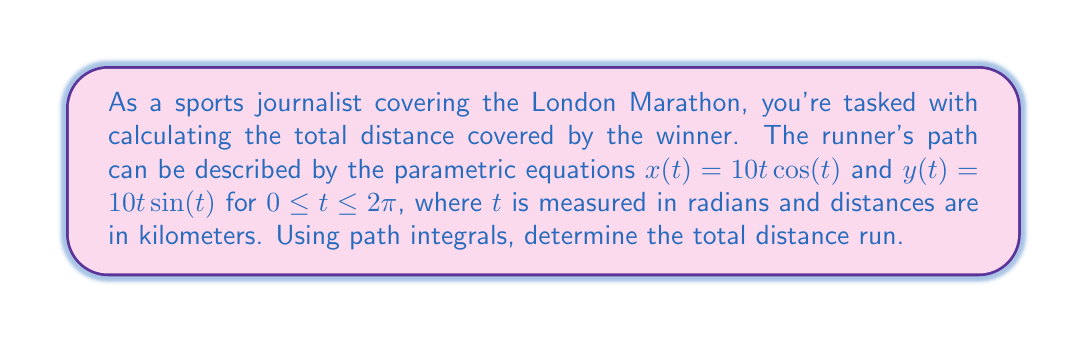What is the answer to this math problem? To solve this problem, we'll use the path integral formula for arc length:

$$L = \int_a^b \sqrt{\left(\frac{dx}{dt}\right)^2 + \left(\frac{dy}{dt}\right)^2} dt$$

Step 1: Calculate $\frac{dx}{dt}$ and $\frac{dy}{dt}$
$\frac{dx}{dt} = 10\cos(t) - 10t\sin(t)$
$\frac{dy}{dt} = 10\sin(t) + 10t\cos(t)$

Step 2: Substitute these into the path integral formula
$$L = \int_0^{2\pi} \sqrt{(10\cos(t) - 10t\sin(t))^2 + (10\sin(t) + 10t\cos(t))^2} dt$$

Step 3: Simplify the expression under the square root
$$(10\cos(t) - 10t\sin(t))^2 + (10\sin(t) + 10t\cos(t))^2$$
$$= 100\cos^2(t) - 200t\cos(t)\sin(t) + 100t^2\sin^2(t) + 100\sin^2(t) + 200t\cos(t)\sin(t) + 100t^2\cos^2(t)$$
$$= 100(\cos^2(t) + \sin^2(t)) + 100t^2(\sin^2(t) + \cos^2(t))$$
$$= 100(1 + t^2)$$

Step 4: Simplify the integral
$$L = \int_0^{2\pi} \sqrt{100(1 + t^2)} dt = 10\int_0^{2\pi} \sqrt{1 + t^2} dt$$

Step 5: This integral doesn't have an elementary antiderivative, so we need to use numerical integration techniques to approximate the result. Using a computer algebra system or numerical integration tool, we find:

$$L \approx 10 \cdot 14.4379 \approx 144.379 \text{ km}$$
Answer: 144.379 km 